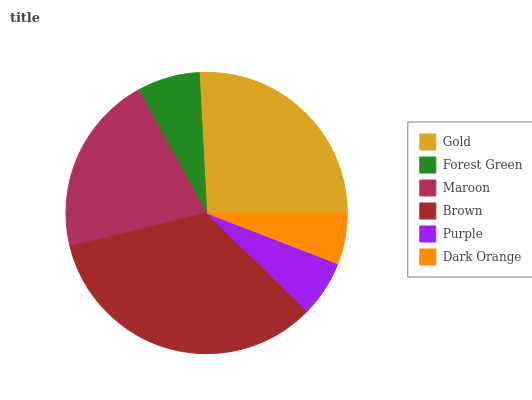Is Dark Orange the minimum?
Answer yes or no. Yes. Is Brown the maximum?
Answer yes or no. Yes. Is Forest Green the minimum?
Answer yes or no. No. Is Forest Green the maximum?
Answer yes or no. No. Is Gold greater than Forest Green?
Answer yes or no. Yes. Is Forest Green less than Gold?
Answer yes or no. Yes. Is Forest Green greater than Gold?
Answer yes or no. No. Is Gold less than Forest Green?
Answer yes or no. No. Is Maroon the high median?
Answer yes or no. Yes. Is Forest Green the low median?
Answer yes or no. Yes. Is Gold the high median?
Answer yes or no. No. Is Brown the low median?
Answer yes or no. No. 